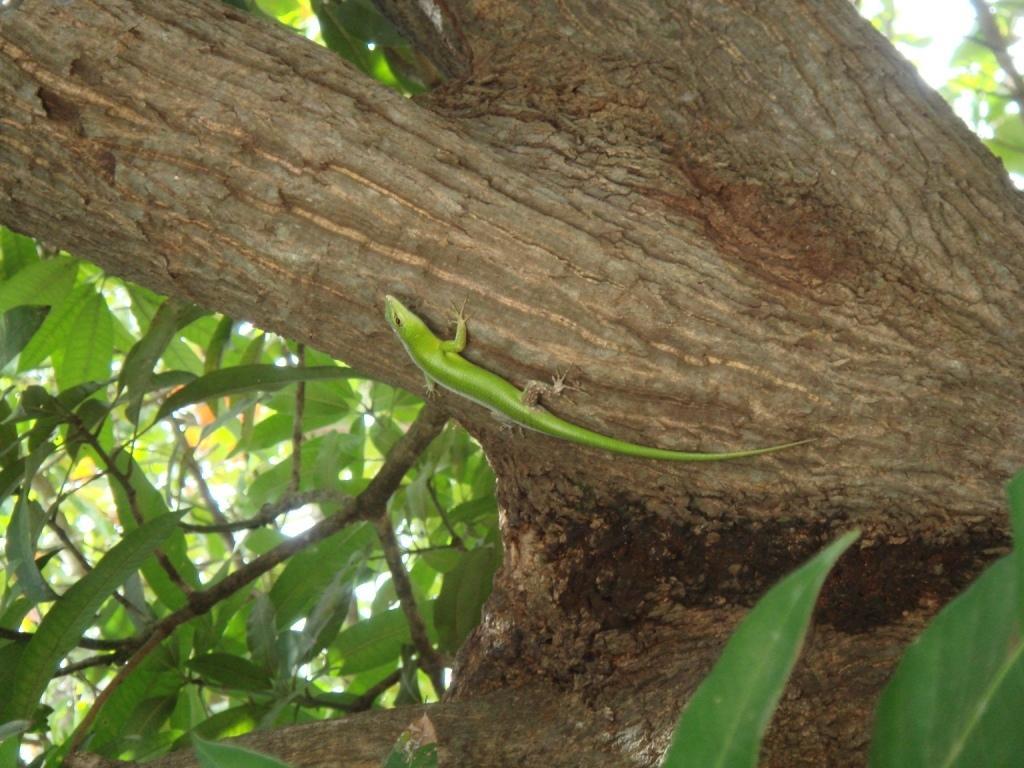Describe this image in one or two sentences. In the image we can see a tree, on the tree there is a lizard. 